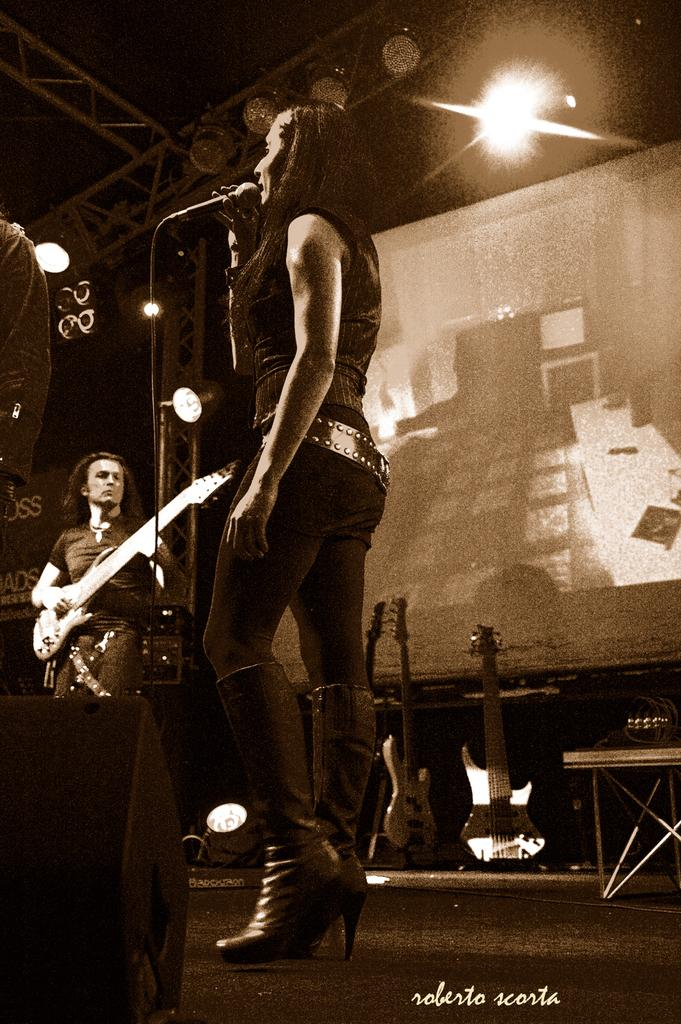What are the people in the image doing? The group of persons in the image are playing musical instruments. Can you describe the attire of one of the persons in the image? There is a person wearing a black color dress in the image. What is the person in the black dress holding in her hand? The person in the black dress is holding a microphone in her hand. Where is the table located in the image? There is no table present in the image. What type of hydrant can be seen in the image? There is no hydrant present in the image. 